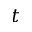Convert formula to latex. <formula><loc_0><loc_0><loc_500><loc_500>t</formula> 